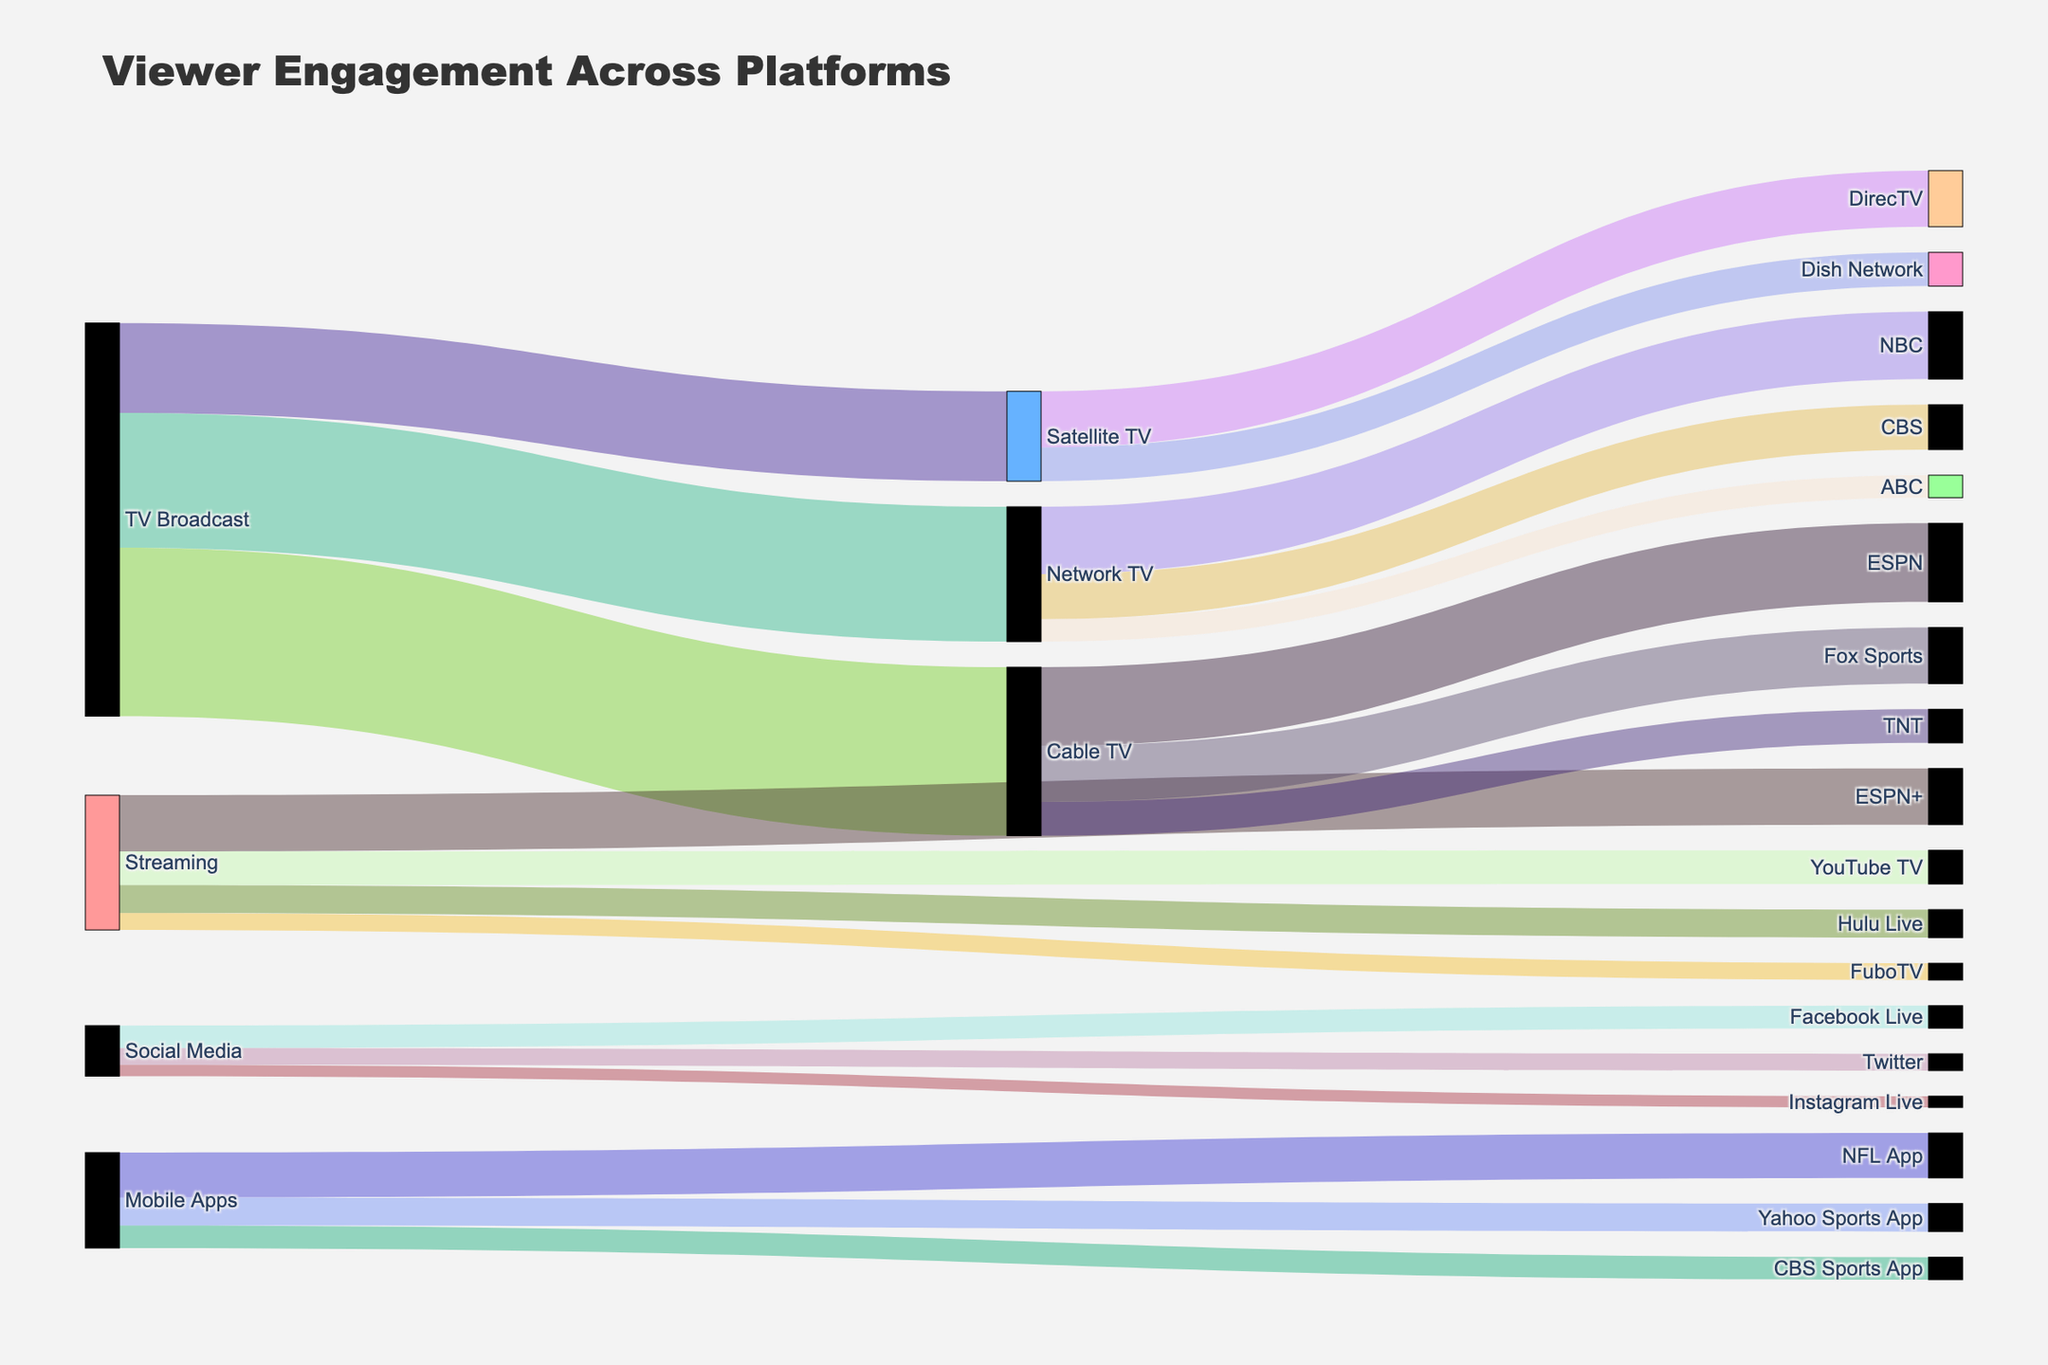What is the title of the plot? The title is usually found at the top of the plot. It provides a summary of what the figure is about.
Answer: Viewer Engagement Across Platforms Which platform in the Streaming source has the highest number of viewers? Look for the streaming source connections and find the platform with the highest associated viewer count.
Answer: ESPN+ How many viewers engage with social media platforms in total? Sum the viewers for Facebook Live, Twitter, and Instagram Live. Add 2000000 (Facebook Live) + 1500000 (Twitter) + 1000000 (Instagram Live).
Answer: 4500000 Compare the number of viewers on Network TV platforms with those on Cable TV platforms. Which has more viewers? Sum the viewers for NBC, CBS, and ABC (Network TV) and ESPN, Fox Sports, and TNT (Cable TV). Network TV: 6000000 + 4000000 + 2000000 = 12000000; Cable TV: 7000000 + 5000000 + 3000000 = 15000000.
Answer: Cable TV What is the difference in viewers between TV Broadcast and Mobile Apps as initial sources? Sum the viewers for TV Broadcast and Mobile Apps; then subtract the total Mobile Apps viewers from the total TV Broadcast viewers. 15000000 + 8000000 + 12000000 (TV Broadcast) - 4000000 + 2500000 + 2000000 (Mobile Apps).
Answer: 26000000 Which Satellite TV platform has fewer viewers, DirecTV or Dish Network? Compare the viewer counts of the two platforms under Satellite TV. Viewers for DirecTV: 5000000; Viewers for Dish Network: 3000000.
Answer: Dish Network How many total viewers tune in through Mobile Apps? Sum the viewers for NFL App, Yahoo Sports App, and CBS Sports App. Add 4000000 + 2500000 + 2000000.
Answer: 8500000 Which source (TV Broadcast, Streaming, Social Media, Mobile Apps) has the highest total number of viewers? Sum the viewers connected to each source and compare their totals.
Answer: TV Broadcast What is the total viewer count for ESPN, including both Cable TV and Streaming sources? Sum the viewers for ESPN under Cable TV and ESPN+ under Streaming. Add 7000000 + 5000000.
Answer: 12000000 